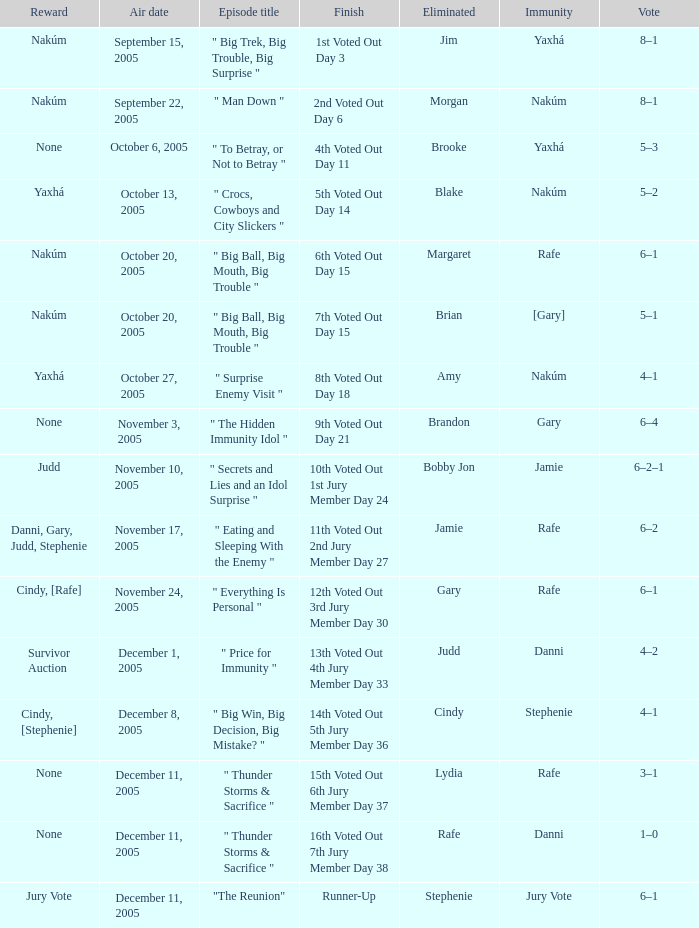How many air dates were there when Morgan was eliminated? 1.0. 